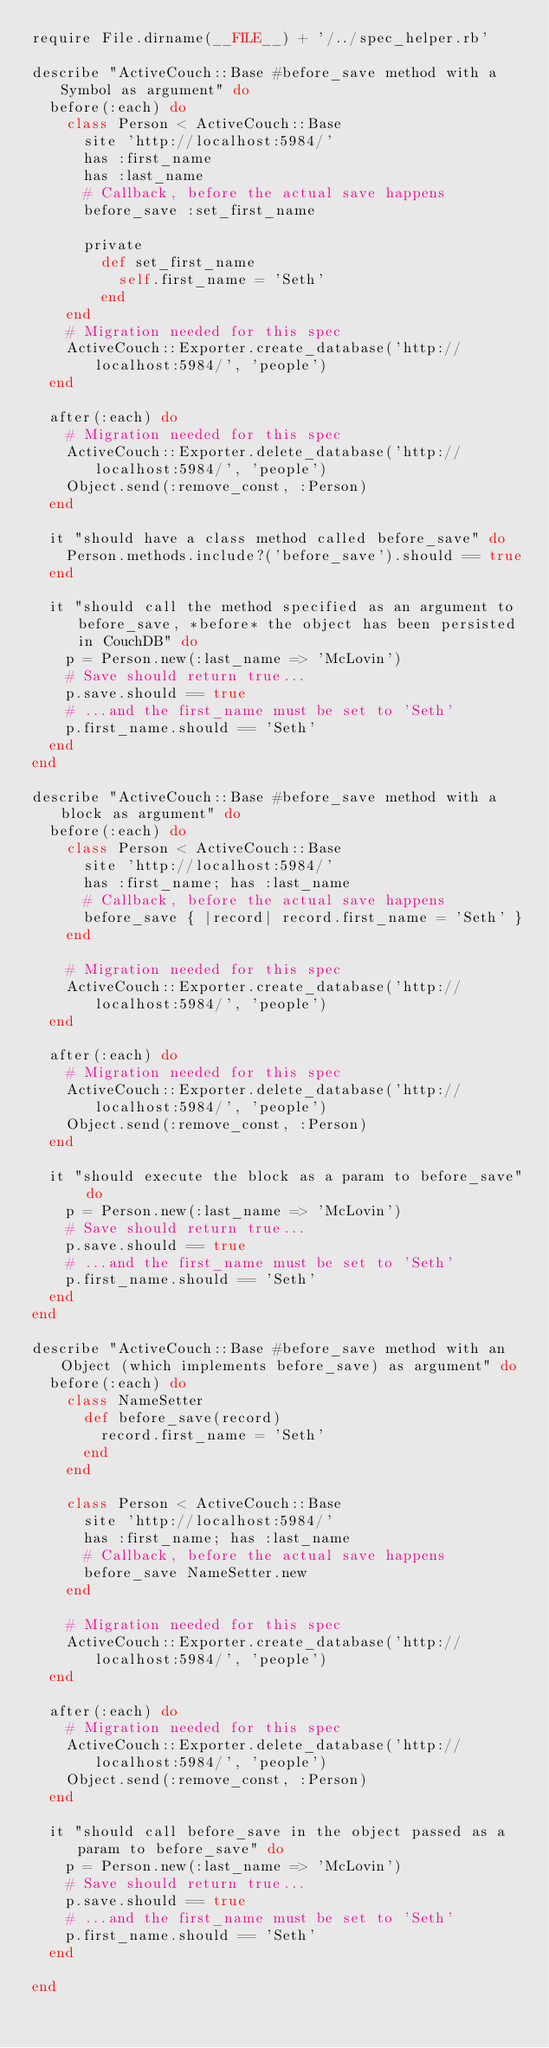Convert code to text. <code><loc_0><loc_0><loc_500><loc_500><_Ruby_>require File.dirname(__FILE__) + '/../spec_helper.rb'

describe "ActiveCouch::Base #before_save method with a Symbol as argument" do
  before(:each) do
    class Person < ActiveCouch::Base
      site 'http://localhost:5984/'
      has :first_name
      has :last_name
      # Callback, before the actual save happens
      before_save :set_first_name
      
      private
        def set_first_name
          self.first_name = 'Seth'
        end
    end
    # Migration needed for this spec
    ActiveCouch::Exporter.create_database('http://localhost:5984/', 'people')
  end
  
  after(:each) do
    # Migration needed for this spec    
    ActiveCouch::Exporter.delete_database('http://localhost:5984/', 'people')
    Object.send(:remove_const, :Person)
  end
  
  it "should have a class method called before_save" do
    Person.methods.include?('before_save').should == true
  end
  
  it "should call the method specified as an argument to before_save, *before* the object has been persisted in CouchDB" do
    p = Person.new(:last_name => 'McLovin')
    # Save should return true...
    p.save.should == true
    # ...and the first_name must be set to 'Seth'
    p.first_name.should == 'Seth'
  end
end

describe "ActiveCouch::Base #before_save method with a block as argument" do
  before(:each) do
    class Person < ActiveCouch::Base
      site 'http://localhost:5984/'
      has :first_name; has :last_name
      # Callback, before the actual save happens
      before_save { |record| record.first_name = 'Seth' }
    end
    
    # Migration needed for this spec
    ActiveCouch::Exporter.create_database('http://localhost:5984/', 'people')
  end
  
  after(:each) do
    # Migration needed for this spec    
    ActiveCouch::Exporter.delete_database('http://localhost:5984/', 'people')
    Object.send(:remove_const, :Person)
  end
  
  it "should execute the block as a param to before_save" do
    p = Person.new(:last_name => 'McLovin')
    # Save should return true...
    p.save.should == true
    # ...and the first_name must be set to 'Seth'
    p.first_name.should == 'Seth'
  end
end

describe "ActiveCouch::Base #before_save method with an Object (which implements before_save) as argument" do
  before(:each) do
    class NameSetter
      def before_save(record)
        record.first_name = 'Seth'
      end
    end
    
    class Person < ActiveCouch::Base
      site 'http://localhost:5984/'
      has :first_name; has :last_name
      # Callback, before the actual save happens
      before_save NameSetter.new
    end
    
    # Migration needed for this spec
    ActiveCouch::Exporter.create_database('http://localhost:5984/', 'people')
  end
  
  after(:each) do
    # Migration needed for this spec    
    ActiveCouch::Exporter.delete_database('http://localhost:5984/', 'people')
    Object.send(:remove_const, :Person)
  end
  
  it "should call before_save in the object passed as a param to before_save" do
    p = Person.new(:last_name => 'McLovin')
    # Save should return true...
    p.save.should == true
    # ...and the first_name must be set to 'Seth'
    p.first_name.should == 'Seth'
  end
      
end</code> 